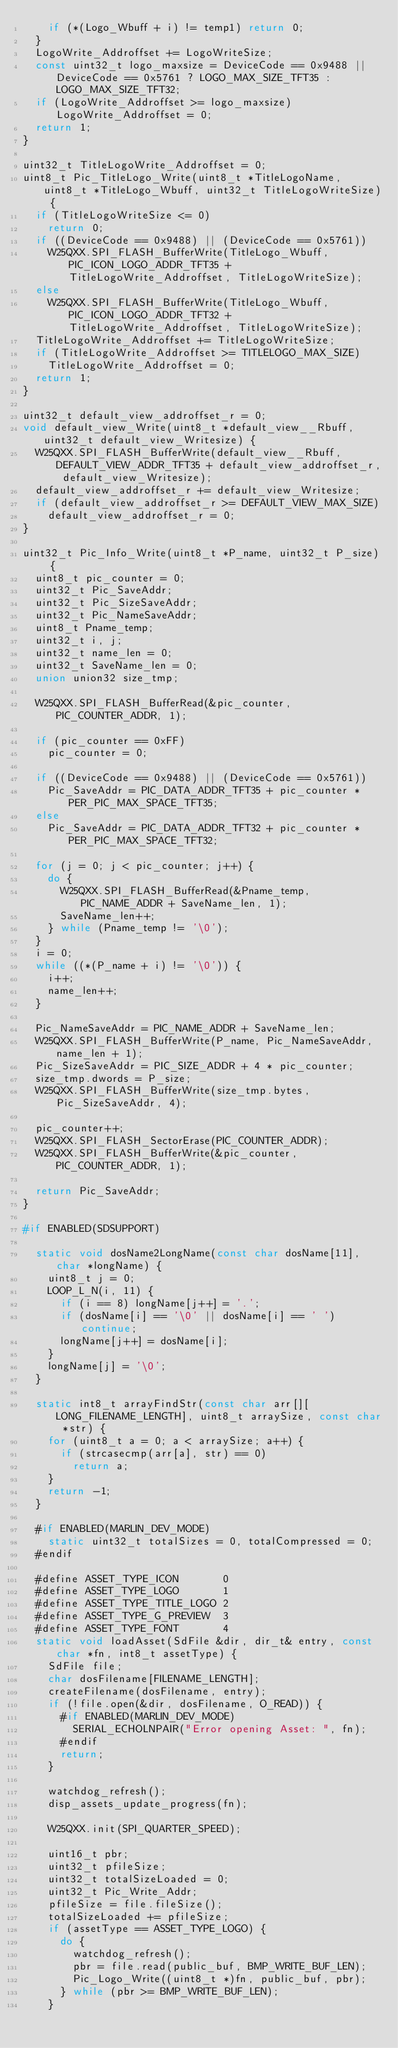<code> <loc_0><loc_0><loc_500><loc_500><_C++_>    if (*(Logo_Wbuff + i) != temp1) return 0;
  }
  LogoWrite_Addroffset += LogoWriteSize;
  const uint32_t logo_maxsize = DeviceCode == 0x9488 || DeviceCode == 0x5761 ? LOGO_MAX_SIZE_TFT35 : LOGO_MAX_SIZE_TFT32;
  if (LogoWrite_Addroffset >= logo_maxsize) LogoWrite_Addroffset = 0;
  return 1;
}

uint32_t TitleLogoWrite_Addroffset = 0;
uint8_t Pic_TitleLogo_Write(uint8_t *TitleLogoName, uint8_t *TitleLogo_Wbuff, uint32_t TitleLogoWriteSize) {
  if (TitleLogoWriteSize <= 0)
    return 0;
  if ((DeviceCode == 0x9488) || (DeviceCode == 0x5761))
    W25QXX.SPI_FLASH_BufferWrite(TitleLogo_Wbuff, PIC_ICON_LOGO_ADDR_TFT35 + TitleLogoWrite_Addroffset, TitleLogoWriteSize);
  else
    W25QXX.SPI_FLASH_BufferWrite(TitleLogo_Wbuff, PIC_ICON_LOGO_ADDR_TFT32 + TitleLogoWrite_Addroffset, TitleLogoWriteSize);
  TitleLogoWrite_Addroffset += TitleLogoWriteSize;
  if (TitleLogoWrite_Addroffset >= TITLELOGO_MAX_SIZE)
    TitleLogoWrite_Addroffset = 0;
  return 1;
}

uint32_t default_view_addroffset_r = 0;
void default_view_Write(uint8_t *default_view__Rbuff, uint32_t default_view_Writesize) {
  W25QXX.SPI_FLASH_BufferWrite(default_view__Rbuff, DEFAULT_VIEW_ADDR_TFT35 + default_view_addroffset_r, default_view_Writesize);
  default_view_addroffset_r += default_view_Writesize;
  if (default_view_addroffset_r >= DEFAULT_VIEW_MAX_SIZE)
    default_view_addroffset_r = 0;
}

uint32_t Pic_Info_Write(uint8_t *P_name, uint32_t P_size) {
  uint8_t pic_counter = 0;
  uint32_t Pic_SaveAddr;
  uint32_t Pic_SizeSaveAddr;
  uint32_t Pic_NameSaveAddr;
  uint8_t Pname_temp;
  uint32_t i, j;
  uint32_t name_len = 0;
  uint32_t SaveName_len = 0;
  union union32 size_tmp;

  W25QXX.SPI_FLASH_BufferRead(&pic_counter, PIC_COUNTER_ADDR, 1);

  if (pic_counter == 0xFF)
    pic_counter = 0;

  if ((DeviceCode == 0x9488) || (DeviceCode == 0x5761))
    Pic_SaveAddr = PIC_DATA_ADDR_TFT35 + pic_counter * PER_PIC_MAX_SPACE_TFT35;
  else
    Pic_SaveAddr = PIC_DATA_ADDR_TFT32 + pic_counter * PER_PIC_MAX_SPACE_TFT32;

  for (j = 0; j < pic_counter; j++) {
    do {
      W25QXX.SPI_FLASH_BufferRead(&Pname_temp, PIC_NAME_ADDR + SaveName_len, 1);
      SaveName_len++;
    } while (Pname_temp != '\0');
  }
  i = 0;
  while ((*(P_name + i) != '\0')) {
    i++;
    name_len++;
  }

  Pic_NameSaveAddr = PIC_NAME_ADDR + SaveName_len;
  W25QXX.SPI_FLASH_BufferWrite(P_name, Pic_NameSaveAddr, name_len + 1);
  Pic_SizeSaveAddr = PIC_SIZE_ADDR + 4 * pic_counter;
  size_tmp.dwords = P_size;
  W25QXX.SPI_FLASH_BufferWrite(size_tmp.bytes, Pic_SizeSaveAddr, 4);

  pic_counter++;
  W25QXX.SPI_FLASH_SectorErase(PIC_COUNTER_ADDR);
  W25QXX.SPI_FLASH_BufferWrite(&pic_counter, PIC_COUNTER_ADDR, 1);

  return Pic_SaveAddr;
}

#if ENABLED(SDSUPPORT)

  static void dosName2LongName(const char dosName[11], char *longName) {
    uint8_t j = 0;
    LOOP_L_N(i, 11) {
      if (i == 8) longName[j++] = '.';
      if (dosName[i] == '\0' || dosName[i] == ' ') continue;
      longName[j++] = dosName[i];
    }
    longName[j] = '\0';
  }

  static int8_t arrayFindStr(const char arr[][LONG_FILENAME_LENGTH], uint8_t arraySize, const char *str) {
    for (uint8_t a = 0; a < arraySize; a++) {
      if (strcasecmp(arr[a], str) == 0)
        return a;
    }
    return -1;
  }

  #if ENABLED(MARLIN_DEV_MODE)
    static uint32_t totalSizes = 0, totalCompressed = 0;
  #endif

  #define ASSET_TYPE_ICON       0
  #define ASSET_TYPE_LOGO       1
  #define ASSET_TYPE_TITLE_LOGO 2
  #define ASSET_TYPE_G_PREVIEW  3
  #define ASSET_TYPE_FONT       4
  static void loadAsset(SdFile &dir, dir_t& entry, const char *fn, int8_t assetType) {
    SdFile file;
    char dosFilename[FILENAME_LENGTH];
    createFilename(dosFilename, entry);
    if (!file.open(&dir, dosFilename, O_READ)) {
      #if ENABLED(MARLIN_DEV_MODE)
        SERIAL_ECHOLNPAIR("Error opening Asset: ", fn);
      #endif
      return;
    }

    watchdog_refresh();
    disp_assets_update_progress(fn);

    W25QXX.init(SPI_QUARTER_SPEED);

    uint16_t pbr;
    uint32_t pfileSize;
    uint32_t totalSizeLoaded = 0;
    uint32_t Pic_Write_Addr;
    pfileSize = file.fileSize();
    totalSizeLoaded += pfileSize;
    if (assetType == ASSET_TYPE_LOGO) {
      do {
        watchdog_refresh();
        pbr = file.read(public_buf, BMP_WRITE_BUF_LEN);
        Pic_Logo_Write((uint8_t *)fn, public_buf, pbr);
      } while (pbr >= BMP_WRITE_BUF_LEN);
    }</code> 